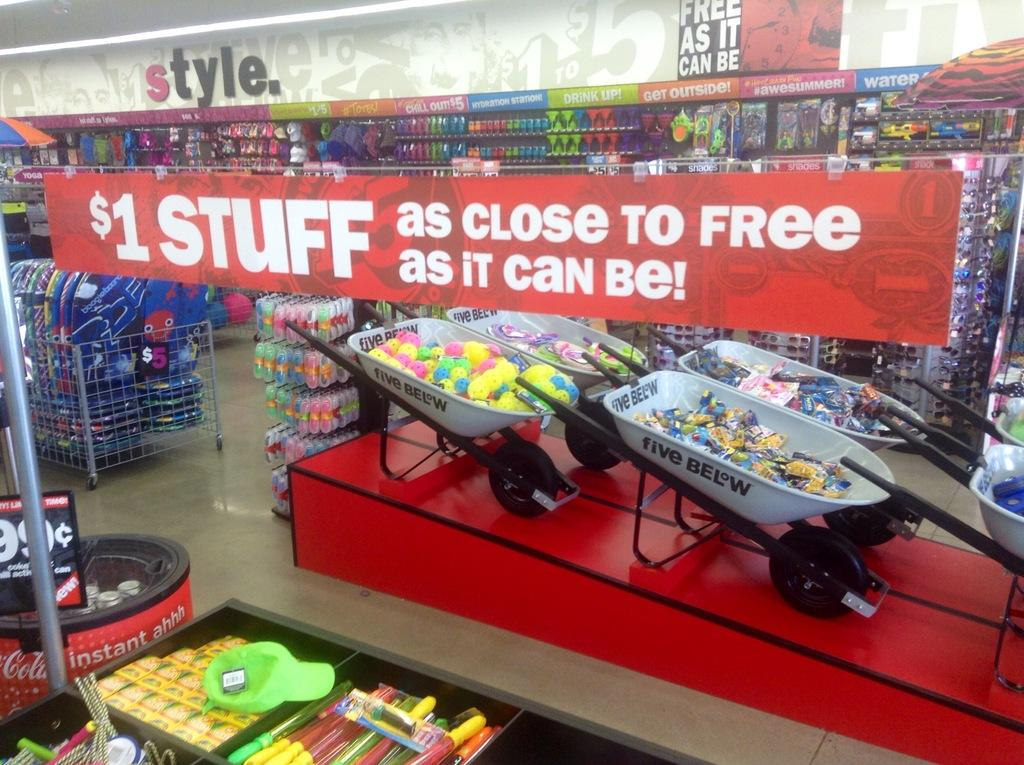<image>
Render a clear and concise summary of the photo. Many products on display below a sign saying "$1 Stuff." 